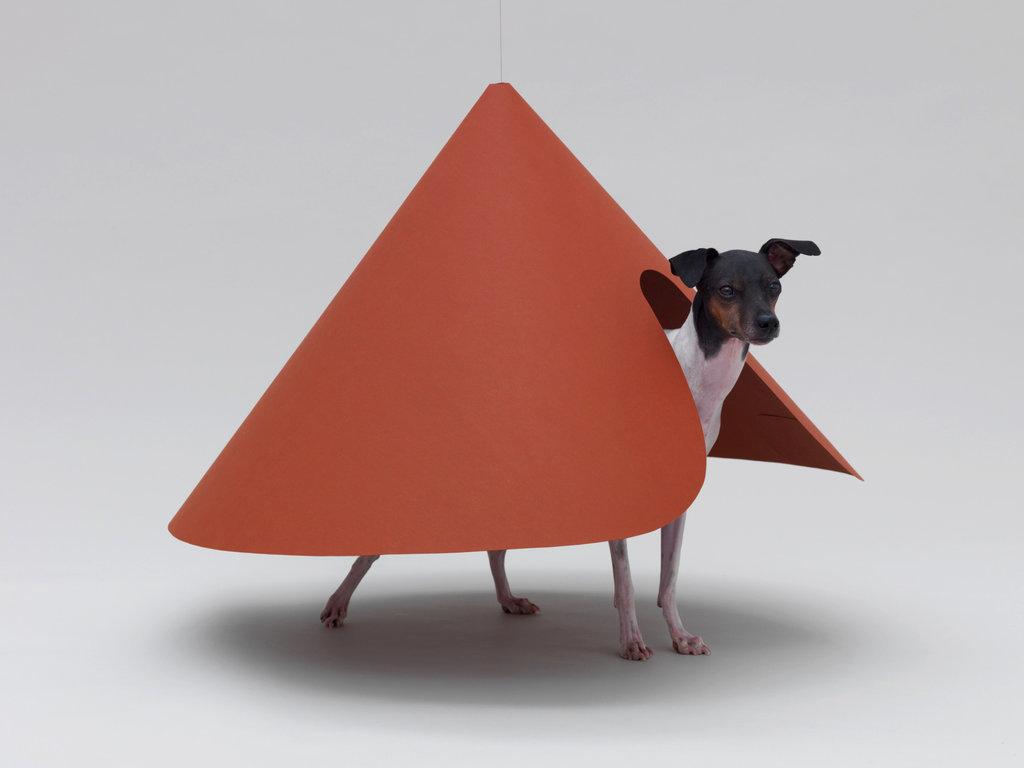What type of animal is in the image? There is a dog in the image. What else can be seen in the image besides the dog? There is an object in the image. What color is the background of the image? The background of the image is white. What type of pen is the dog holding in the image? There is no pen present in the image, and the dog is not holding anything. 